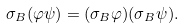<formula> <loc_0><loc_0><loc_500><loc_500>\sigma _ { B } ( \varphi \psi ) = ( \sigma _ { B } \varphi ) ( \sigma _ { B } \psi ) .</formula> 